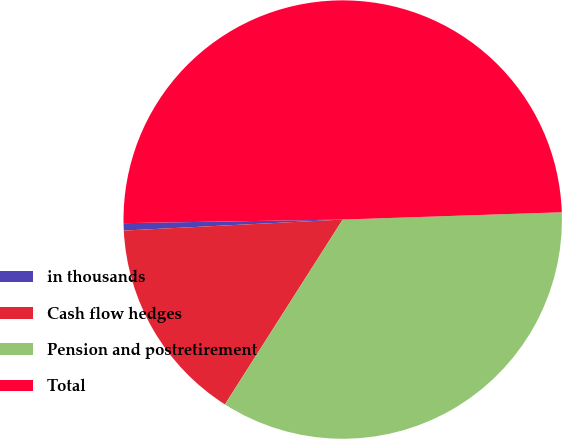Convert chart. <chart><loc_0><loc_0><loc_500><loc_500><pie_chart><fcel>in thousands<fcel>Cash flow hedges<fcel>Pension and postretirement<fcel>Total<nl><fcel>0.54%<fcel>15.17%<fcel>34.56%<fcel>49.73%<nl></chart> 